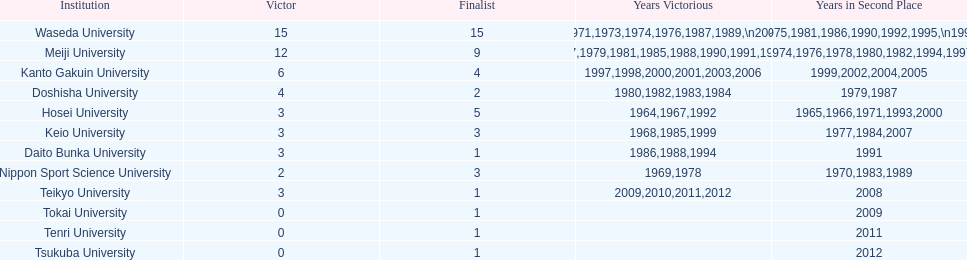Hosei won in 1964. who won the next year? Waseda University. 